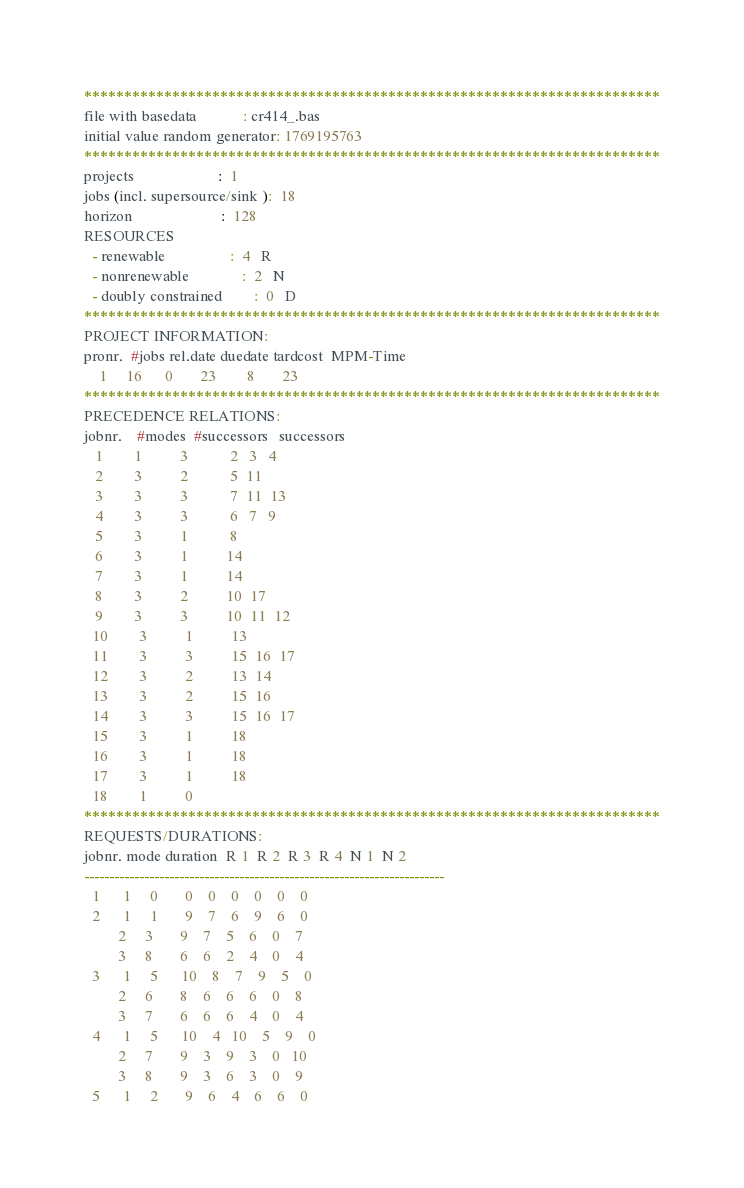<code> <loc_0><loc_0><loc_500><loc_500><_ObjectiveC_>************************************************************************
file with basedata            : cr414_.bas
initial value random generator: 1769195763
************************************************************************
projects                      :  1
jobs (incl. supersource/sink ):  18
horizon                       :  128
RESOURCES
  - renewable                 :  4   R
  - nonrenewable              :  2   N
  - doubly constrained        :  0   D
************************************************************************
PROJECT INFORMATION:
pronr.  #jobs rel.date duedate tardcost  MPM-Time
    1     16      0       23        8       23
************************************************************************
PRECEDENCE RELATIONS:
jobnr.    #modes  #successors   successors
   1        1          3           2   3   4
   2        3          2           5  11
   3        3          3           7  11  13
   4        3          3           6   7   9
   5        3          1           8
   6        3          1          14
   7        3          1          14
   8        3          2          10  17
   9        3          3          10  11  12
  10        3          1          13
  11        3          3          15  16  17
  12        3          2          13  14
  13        3          2          15  16
  14        3          3          15  16  17
  15        3          1          18
  16        3          1          18
  17        3          1          18
  18        1          0        
************************************************************************
REQUESTS/DURATIONS:
jobnr. mode duration  R 1  R 2  R 3  R 4  N 1  N 2
------------------------------------------------------------------------
  1      1     0       0    0    0    0    0    0
  2      1     1       9    7    6    9    6    0
         2     3       9    7    5    6    0    7
         3     8       6    6    2    4    0    4
  3      1     5      10    8    7    9    5    0
         2     6       8    6    6    6    0    8
         3     7       6    6    6    4    0    4
  4      1     5      10    4   10    5    9    0
         2     7       9    3    9    3    0   10
         3     8       9    3    6    3    0    9
  5      1     2       9    6    4    6    6    0</code> 